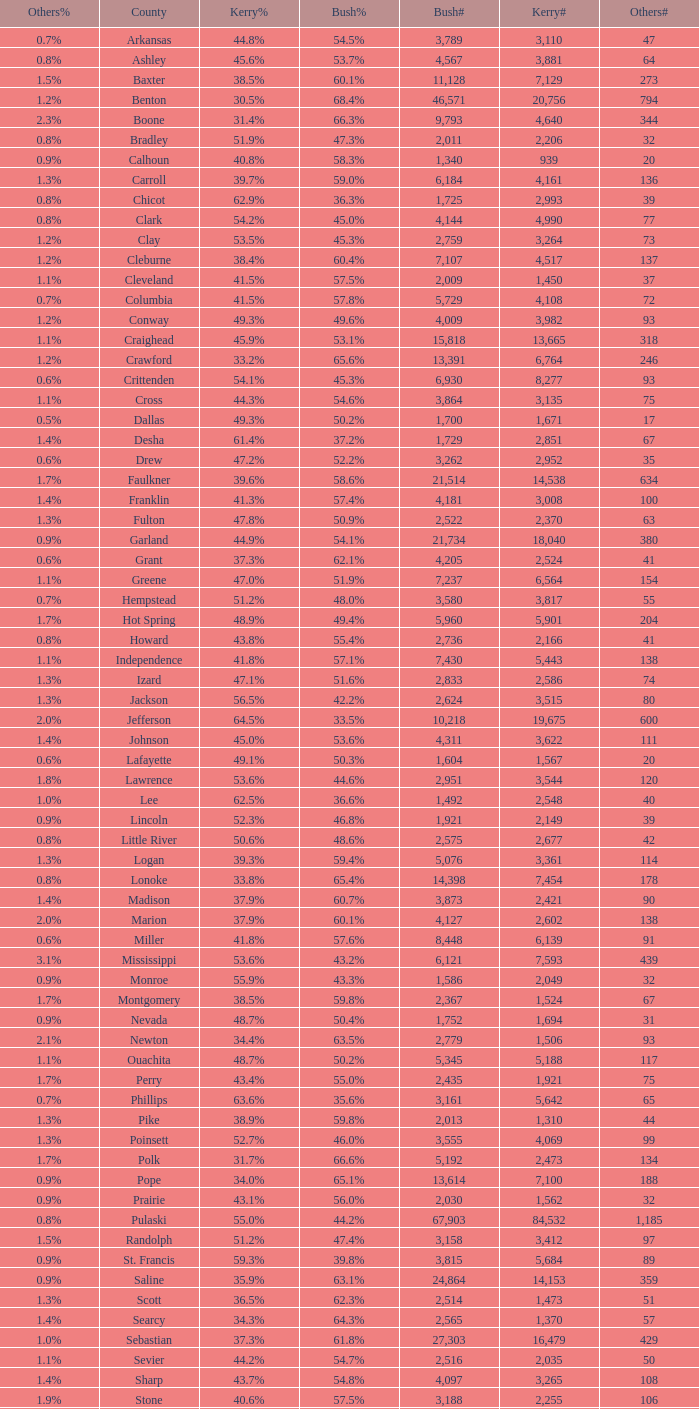What is the lowest Kerry#, when Others# is "106", and when Bush# is less than 3,188? None. 